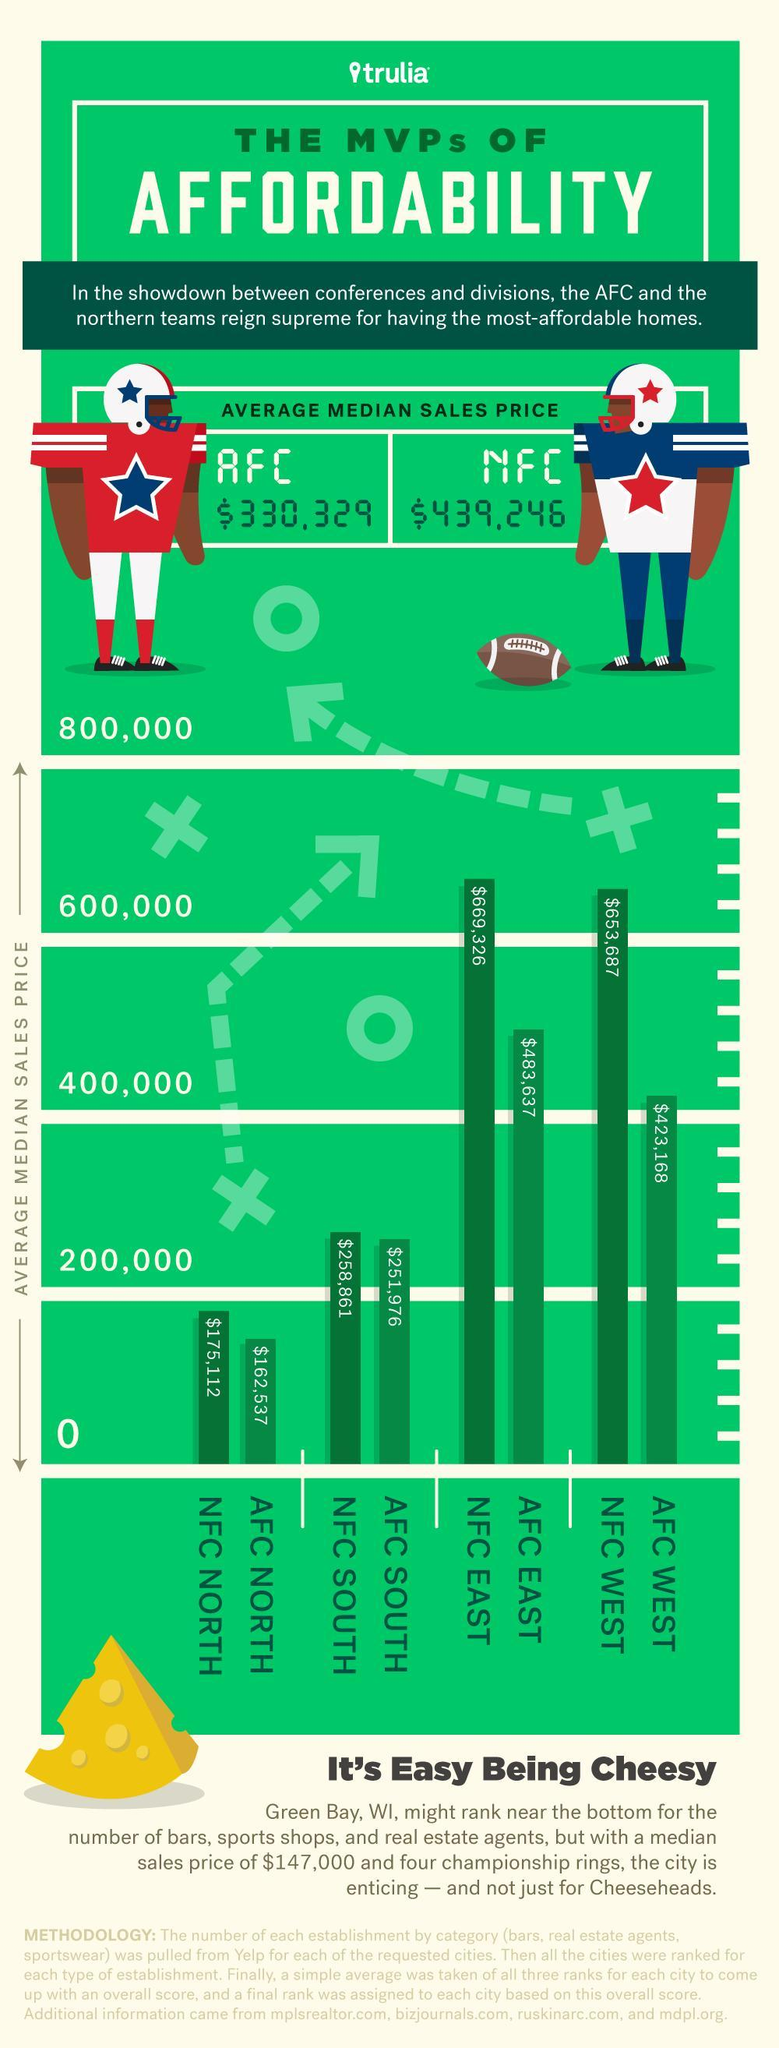How many AFC divisions have an average median sales price less than $200,000?
Answer the question with a short phrase. 1 How many divisions are in AFC? 4 Which NFC division has the average median sales price less than $200,000? NFC NORTH What is the average median sales price of NFC WEST? $653,687 Which NFC division has the average median sales price between $200,000 - $400,000? NFC SOUTH What is the average median sales price of AFC WEST? $423,168 Which AFC division has the lowest average median sales price? AFC NORTH What is the average median sales price of NFC East? $669,326 Which AFC division has the maximum average median sales price? AFC EAST What is the number of NFC division having an average median sales price of above $600,000? 2 